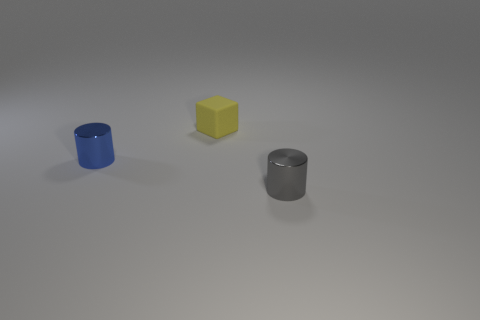The tiny matte block is what color? yellow 